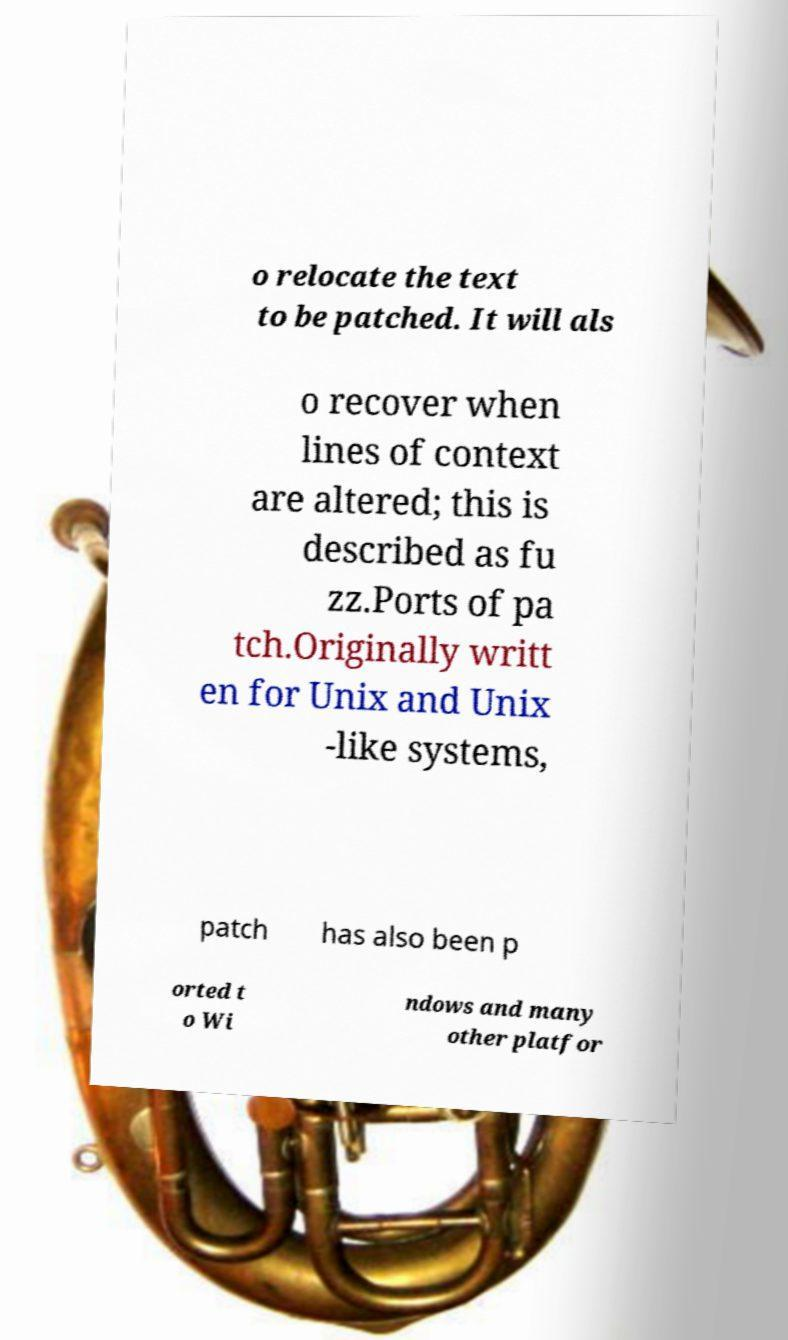Can you read and provide the text displayed in the image?This photo seems to have some interesting text. Can you extract and type it out for me? o relocate the text to be patched. It will als o recover when lines of context are altered; this is described as fu zz.Ports of pa tch.Originally writt en for Unix and Unix -like systems, patch has also been p orted t o Wi ndows and many other platfor 